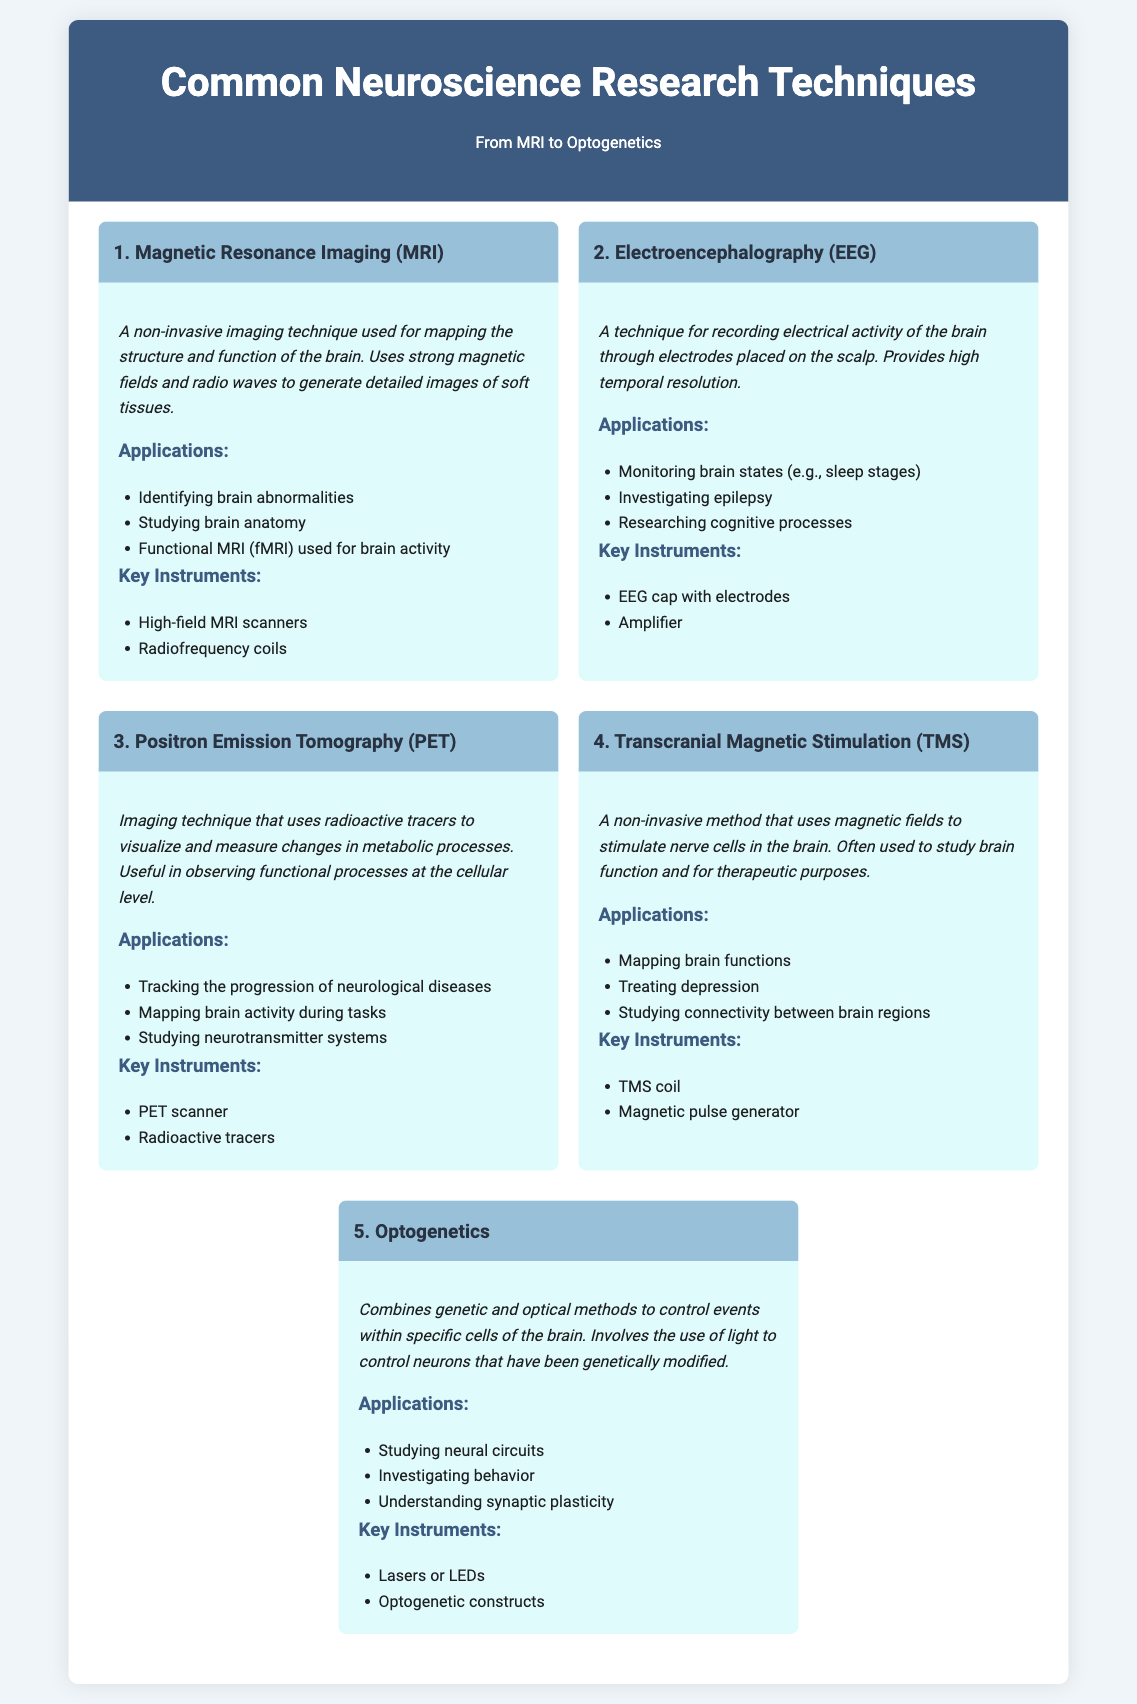What is the first neuroscience research technique listed? The document lists "Magnetic Resonance Imaging (MRI)" as the first technique in the infographic.
Answer: Magnetic Resonance Imaging (MRI) What is the main purpose of Electroencephalography (EEG)? The main purpose of EEG is to record electrical activity of the brain through electrodes placed on the scalp.
Answer: Recording electrical activity What type of imaging does Positron Emission Tomography (PET) use? PET uses radioactive tracers to visualize and measure changes in metabolic processes in the brain.
Answer: Radioactive tracers Which technique is used for mapping brain functions and treating depression? Transcranial Magnetic Stimulation (TMS) is specifically used for mapping brain functions and can also be therapeutic for depression.
Answer: Transcranial Magnetic Stimulation (TMS) How many key instruments are listed for Optogenetics? The document mentions two key instruments associated with Optogenetics.
Answer: Two Which technique provides the highest temporal resolution? The document states that Electroencephalography (EEG) provides high temporal resolution for brain activity monitoring.
Answer: Electroencephalography (EEG) What new method combines genetic and optical techniques? The document introduces "Optogenetics" as a technique that combines genetic and optical methods.
Answer: Optogenetics Which technique is often used for therapeutic purposes? The document indicates that Transcranial Magnetic Stimulation (TMS) is often used for therapeutic purposes.
Answer: Transcranial Magnetic Stimulation (TMS) What is a key application of Magnetic Resonance Imaging (MRI)? One key application of MRI is "Identifying brain abnormalities," as stated in the document.
Answer: Identifying brain abnormalities 